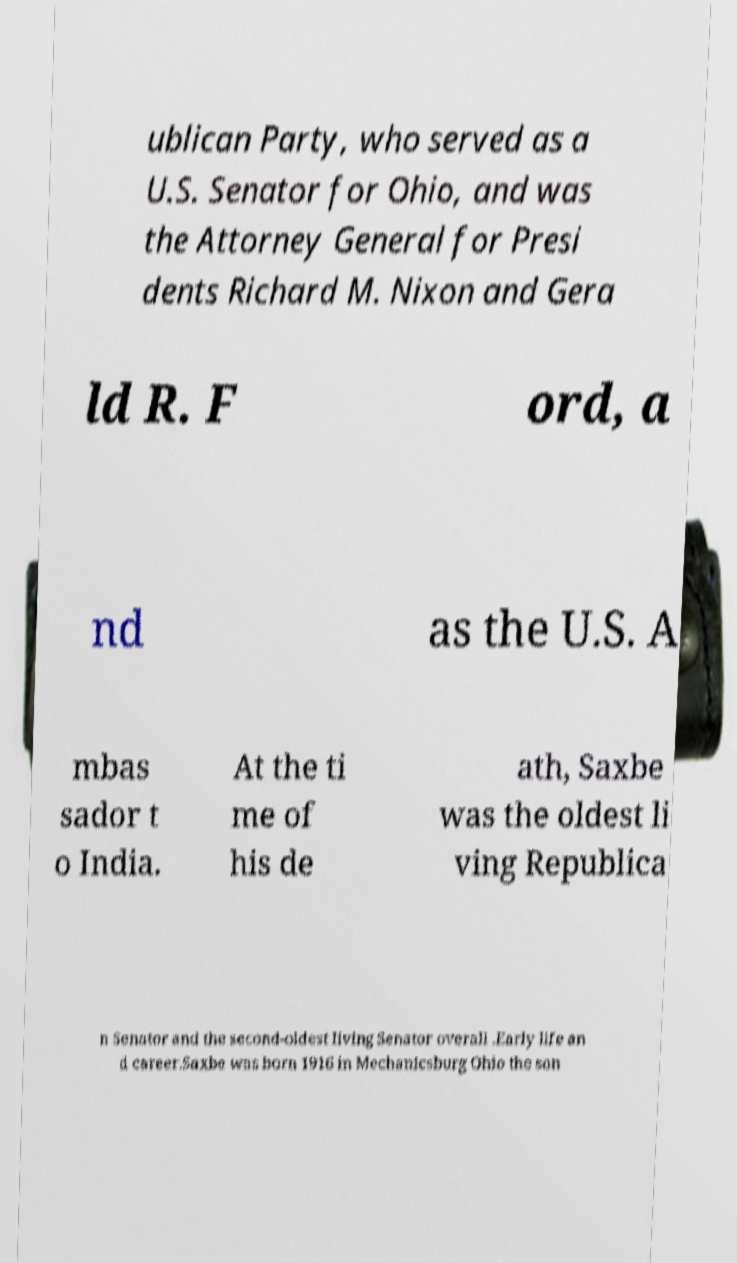What messages or text are displayed in this image? I need them in a readable, typed format. ublican Party, who served as a U.S. Senator for Ohio, and was the Attorney General for Presi dents Richard M. Nixon and Gera ld R. F ord, a nd as the U.S. A mbas sador t o India. At the ti me of his de ath, Saxbe was the oldest li ving Republica n Senator and the second-oldest living Senator overall .Early life an d career.Saxbe was born 1916 in Mechanicsburg Ohio the son 